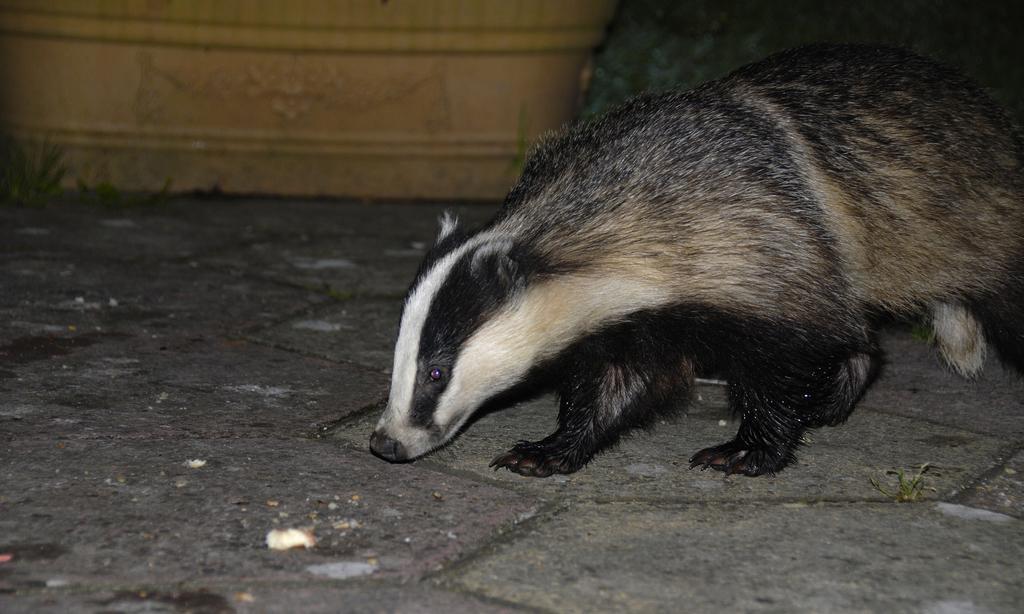In one or two sentences, can you explain what this image depicts? In this image we can see a badger on the land. On the backside we can see a wall. 